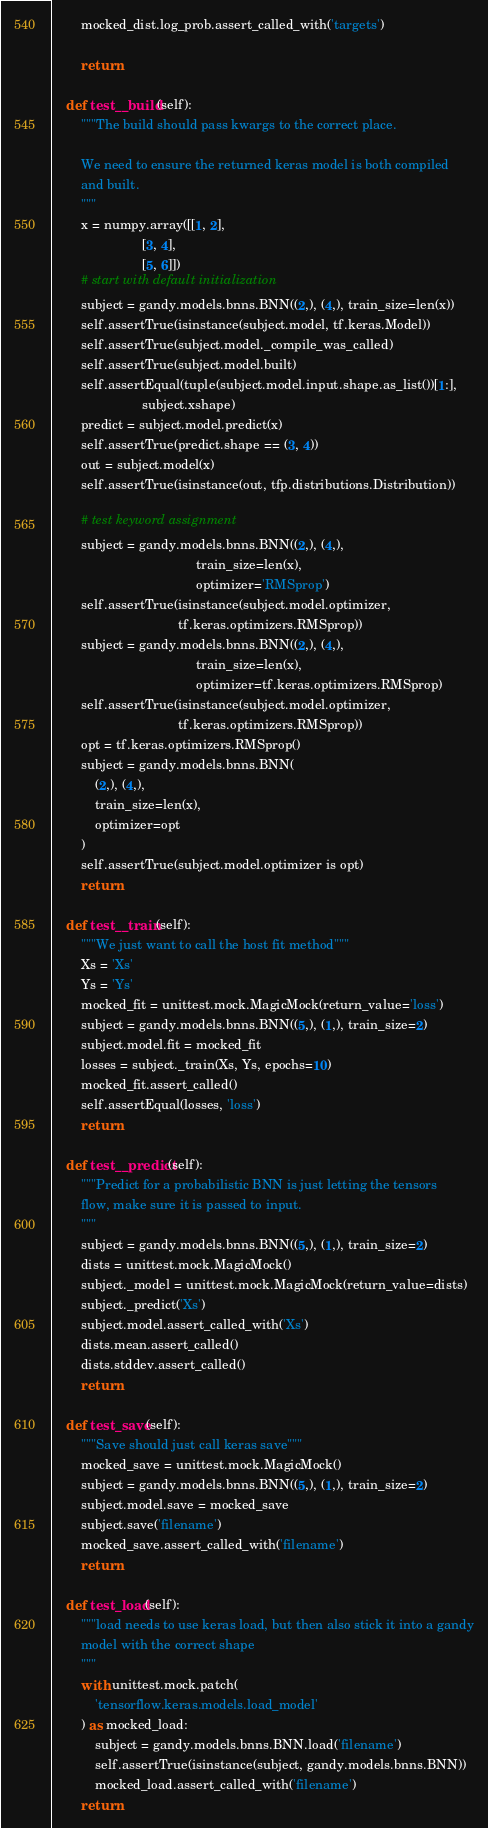Convert code to text. <code><loc_0><loc_0><loc_500><loc_500><_Python_>        mocked_dist.log_prob.assert_called_with('targets')

        return

    def test__build(self):
        """The build should pass kwargs to the correct place.

        We need to ensure the returned keras model is both compiled
        and built.
        """
        x = numpy.array([[1, 2],
                         [3, 4],
                         [5, 6]])
        # start with default initialization
        subject = gandy.models.bnns.BNN((2,), (4,), train_size=len(x))
        self.assertTrue(isinstance(subject.model, tf.keras.Model))
        self.assertTrue(subject.model._compile_was_called)
        self.assertTrue(subject.model.built)
        self.assertEqual(tuple(subject.model.input.shape.as_list())[1:],
                         subject.xshape)
        predict = subject.model.predict(x)
        self.assertTrue(predict.shape == (3, 4))
        out = subject.model(x)
        self.assertTrue(isinstance(out, tfp.distributions.Distribution))

        # test keyword assignment
        subject = gandy.models.bnns.BNN((2,), (4,),
                                        train_size=len(x),
                                        optimizer='RMSprop')
        self.assertTrue(isinstance(subject.model.optimizer,
                                   tf.keras.optimizers.RMSprop))
        subject = gandy.models.bnns.BNN((2,), (4,),
                                        train_size=len(x),
                                        optimizer=tf.keras.optimizers.RMSprop)
        self.assertTrue(isinstance(subject.model.optimizer,
                                   tf.keras.optimizers.RMSprop))
        opt = tf.keras.optimizers.RMSprop()
        subject = gandy.models.bnns.BNN(
            (2,), (4,),
            train_size=len(x),
            optimizer=opt
        )
        self.assertTrue(subject.model.optimizer is opt)
        return

    def test__train(self):
        """We just want to call the host fit method"""
        Xs = 'Xs'
        Ys = 'Ys'
        mocked_fit = unittest.mock.MagicMock(return_value='loss')
        subject = gandy.models.bnns.BNN((5,), (1,), train_size=2)
        subject.model.fit = mocked_fit
        losses = subject._train(Xs, Ys, epochs=10)
        mocked_fit.assert_called()
        self.assertEqual(losses, 'loss')
        return

    def test__predict(self):
        """Predict for a probabilistic BNN is just letting the tensors
        flow, make sure it is passed to input.
        """
        subject = gandy.models.bnns.BNN((5,), (1,), train_size=2)
        dists = unittest.mock.MagicMock()
        subject._model = unittest.mock.MagicMock(return_value=dists)
        subject._predict('Xs')
        subject.model.assert_called_with('Xs')
        dists.mean.assert_called()
        dists.stddev.assert_called()
        return

    def test_save(self):
        """Save should just call keras save"""
        mocked_save = unittest.mock.MagicMock()
        subject = gandy.models.bnns.BNN((5,), (1,), train_size=2)
        subject.model.save = mocked_save
        subject.save('filename')
        mocked_save.assert_called_with('filename')
        return

    def test_load(self):
        """load needs to use keras load, but then also stick it into a gandy
        model with the correct shape
        """
        with unittest.mock.patch(
            'tensorflow.keras.models.load_model'
        ) as mocked_load:
            subject = gandy.models.bnns.BNN.load('filename')
            self.assertTrue(isinstance(subject, gandy.models.bnns.BNN))
            mocked_load.assert_called_with('filename')
        return
</code> 